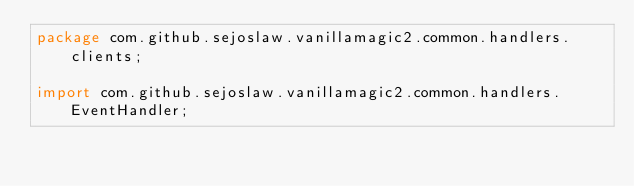Convert code to text. <code><loc_0><loc_0><loc_500><loc_500><_Java_>package com.github.sejoslaw.vanillamagic2.common.handlers.clients;

import com.github.sejoslaw.vanillamagic2.common.handlers.EventHandler;</code> 